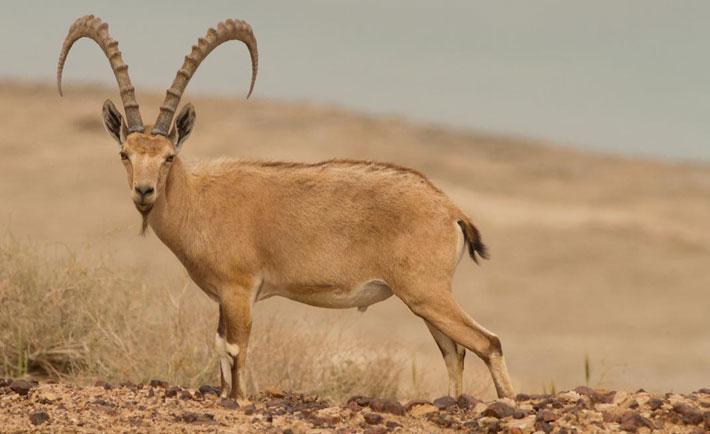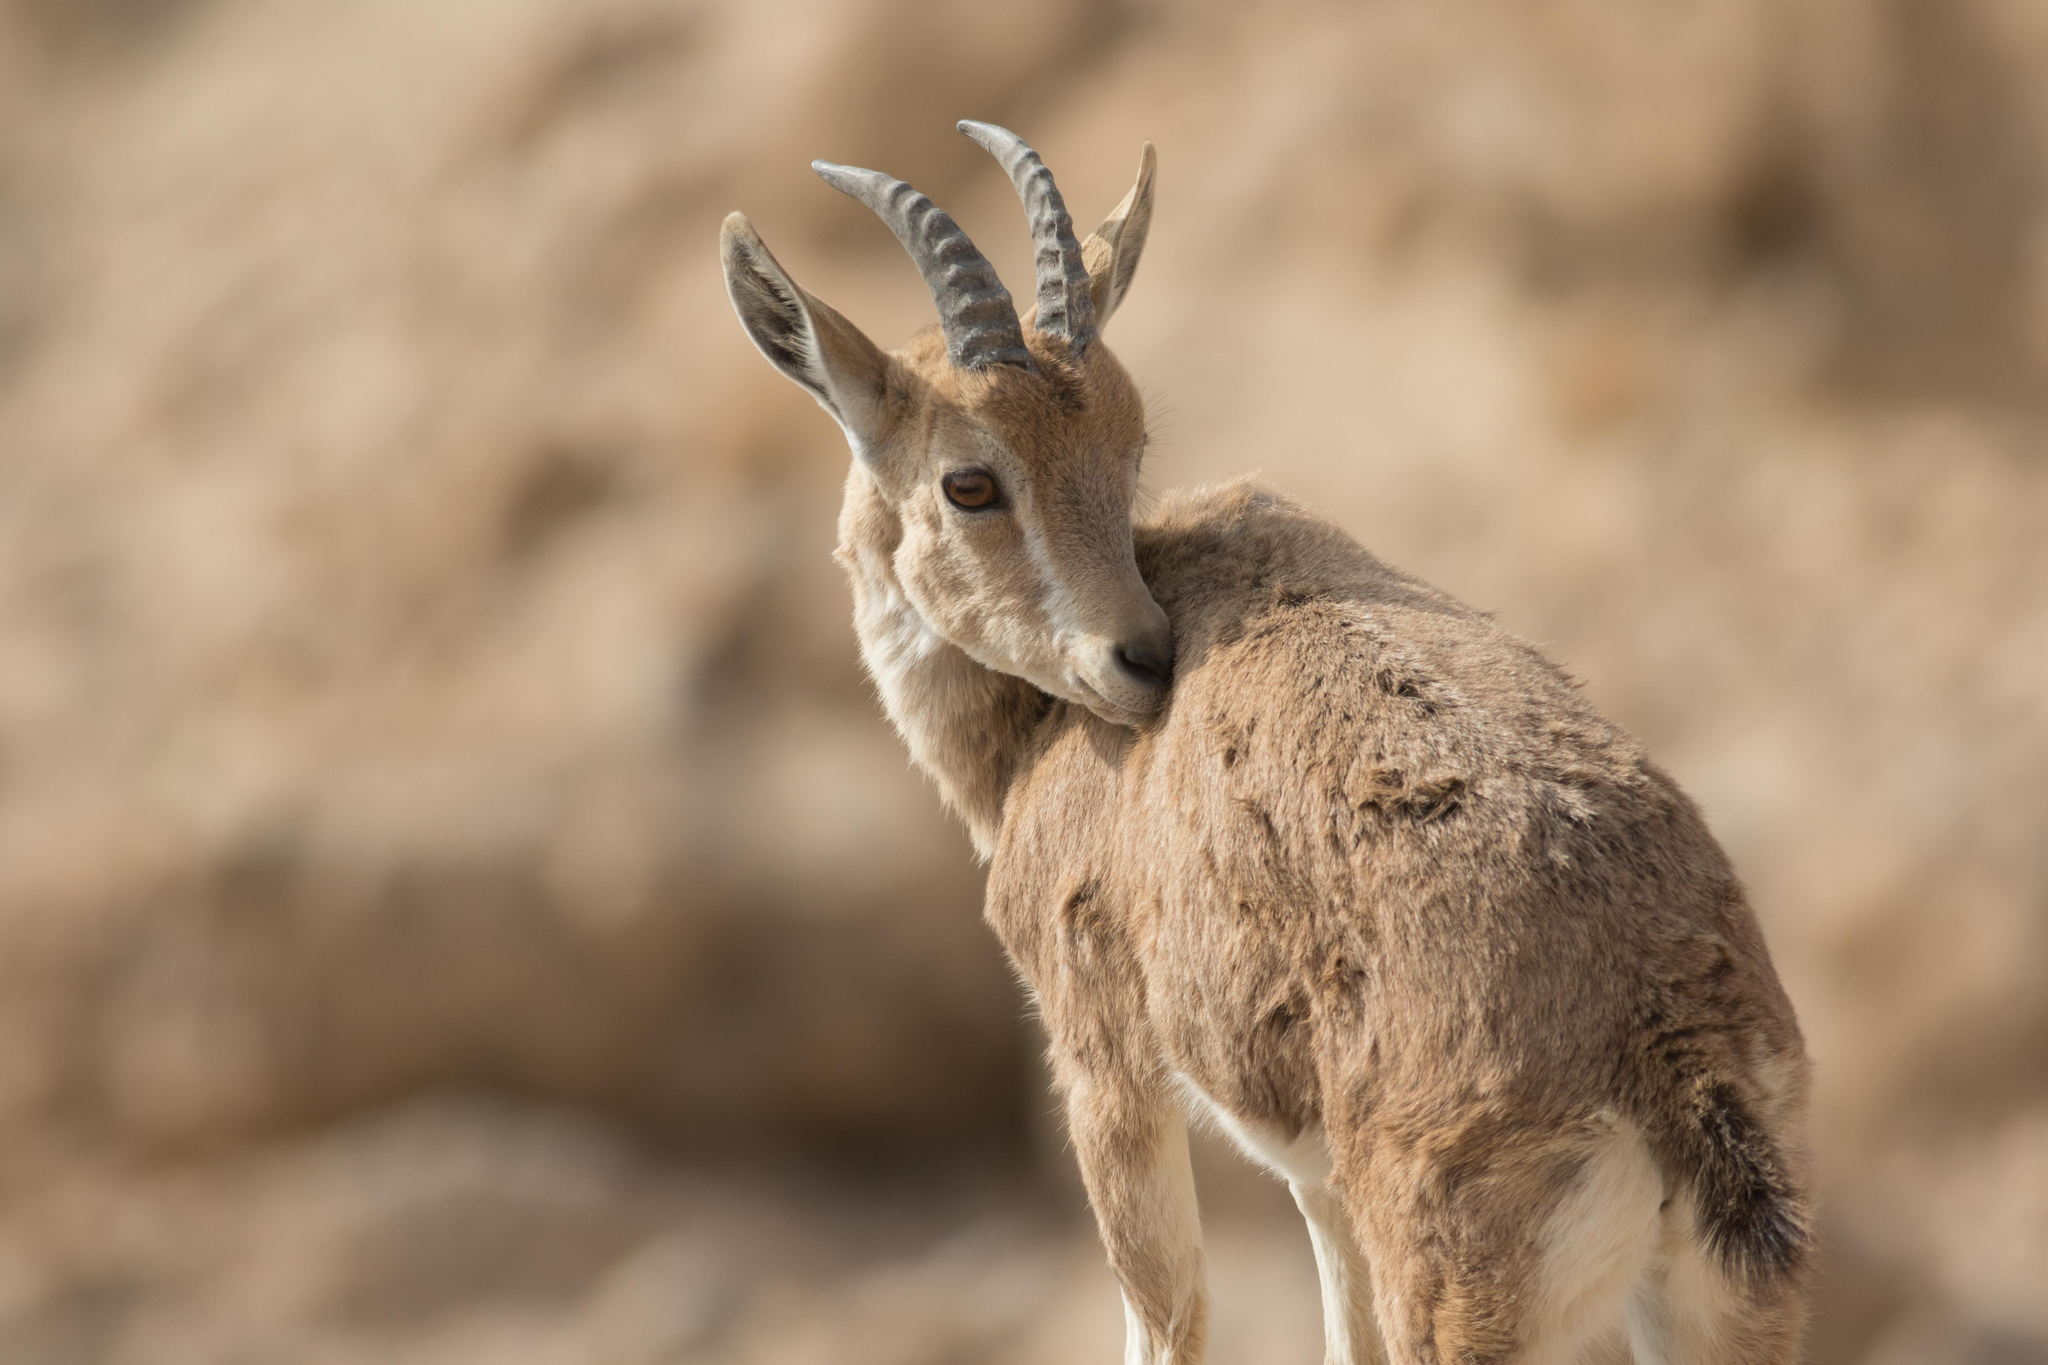The first image is the image on the left, the second image is the image on the right. Evaluate the accuracy of this statement regarding the images: "In the left image, one horned animal looks directly at the camera.". Is it true? Answer yes or no. Yes. The first image is the image on the left, the second image is the image on the right. Examine the images to the left and right. Is the description "In one image, at least one horned animal is lying down with its legs tucked under it." accurate? Answer yes or no. No. 